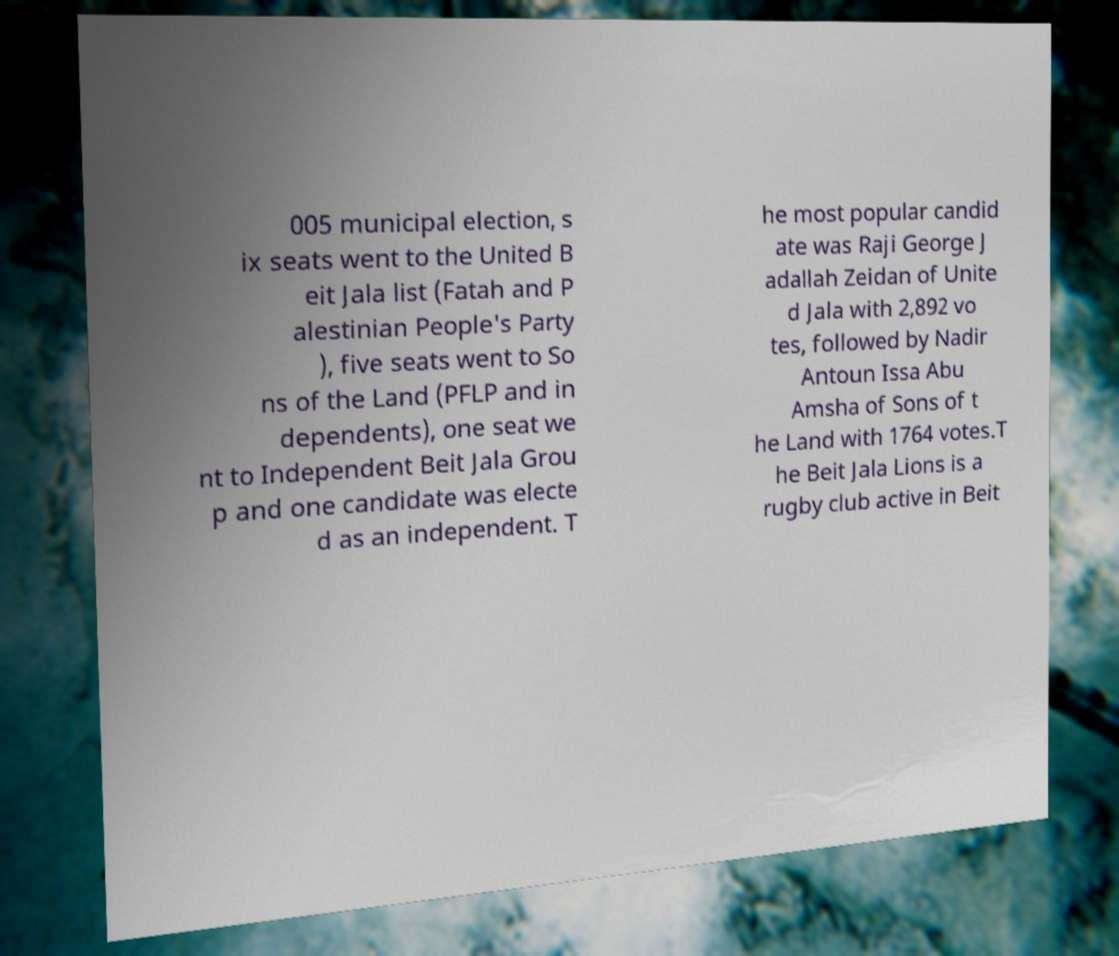There's text embedded in this image that I need extracted. Can you transcribe it verbatim? 005 municipal election, s ix seats went to the United B eit Jala list (Fatah and P alestinian People's Party ), five seats went to So ns of the Land (PFLP and in dependents), one seat we nt to Independent Beit Jala Grou p and one candidate was electe d as an independent. T he most popular candid ate was Raji George J adallah Zeidan of Unite d Jala with 2,892 vo tes, followed by Nadir Antoun Issa Abu Amsha of Sons of t he Land with 1764 votes.T he Beit Jala Lions is a rugby club active in Beit 